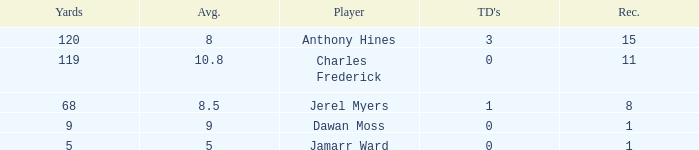What is the total Avg when TDs are 0 and Dawan Moss is a player? 0.0. 